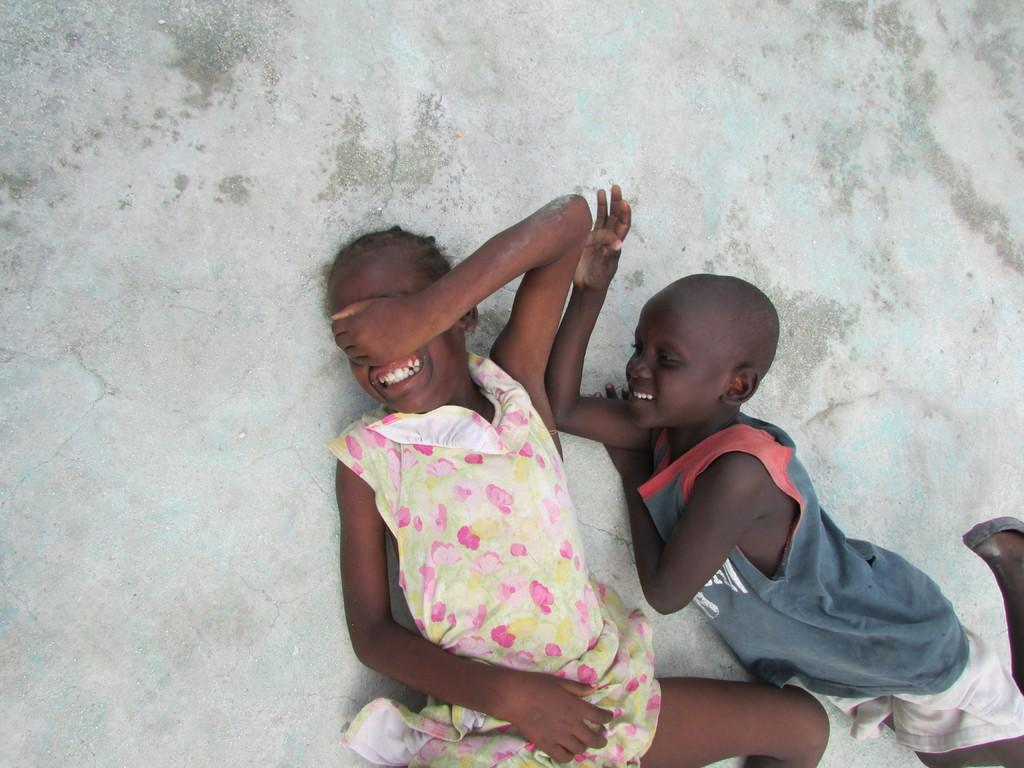What are the two people in the image doing? There is a girl and a boy lying on the floor in the image. How is the boy feeling in the image? The boy is smiling in the image. What color is the background of the image? The background of the image is gray in color. What type of unit is being used to measure the distance between the girl and the boy in the image? There is no unit mentioned or implied in the image, as it is focused on the people and their actions. 